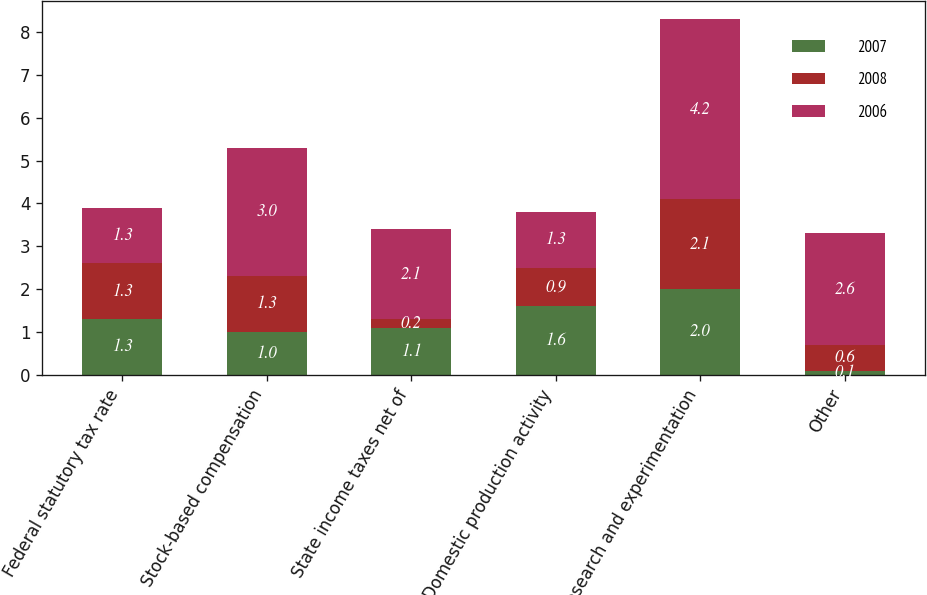<chart> <loc_0><loc_0><loc_500><loc_500><stacked_bar_chart><ecel><fcel>Federal statutory tax rate<fcel>Stock-based compensation<fcel>State income taxes net of<fcel>Domestic production activity<fcel>Research and experimentation<fcel>Other<nl><fcel>2007<fcel>1.3<fcel>1<fcel>1.1<fcel>1.6<fcel>2<fcel>0.1<nl><fcel>2008<fcel>1.3<fcel>1.3<fcel>0.2<fcel>0.9<fcel>2.1<fcel>0.6<nl><fcel>2006<fcel>1.3<fcel>3<fcel>2.1<fcel>1.3<fcel>4.2<fcel>2.6<nl></chart> 